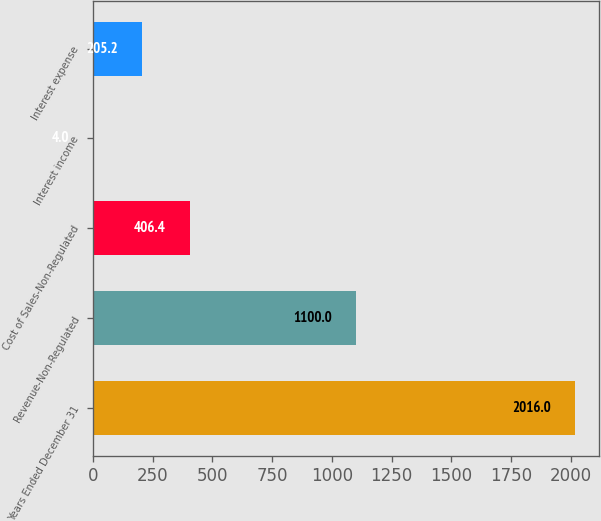Convert chart. <chart><loc_0><loc_0><loc_500><loc_500><bar_chart><fcel>Years Ended December 31<fcel>Revenue-Non-Regulated<fcel>Cost of Sales-Non-Regulated<fcel>Interest income<fcel>Interest expense<nl><fcel>2016<fcel>1100<fcel>406.4<fcel>4<fcel>205.2<nl></chart> 